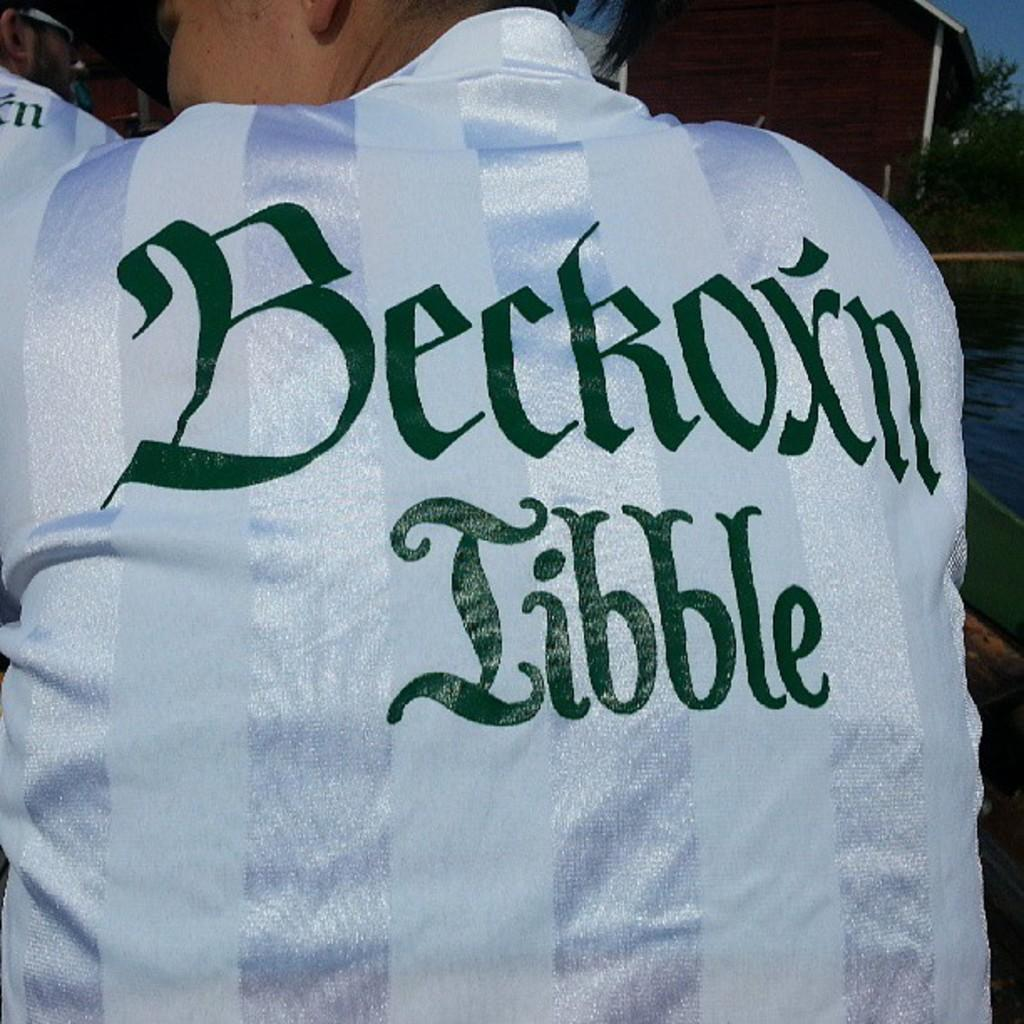What is the main subject in the middle of the image? There is a jersey in the middle of the image. Is anyone wearing the jersey? Yes, a person is wearing the jersey. What can be seen in the right side top corner of the image? There is a building in the right side top corner of the image. What is located beside the building in the image? There is a tree beside the building in the image. What type of friction can be seen between the jersey and the person wearing it in the image? There is no visible friction between the jersey and the person wearing it in the image. Can you see any quiver in the image? There is no quiver present in the image. 